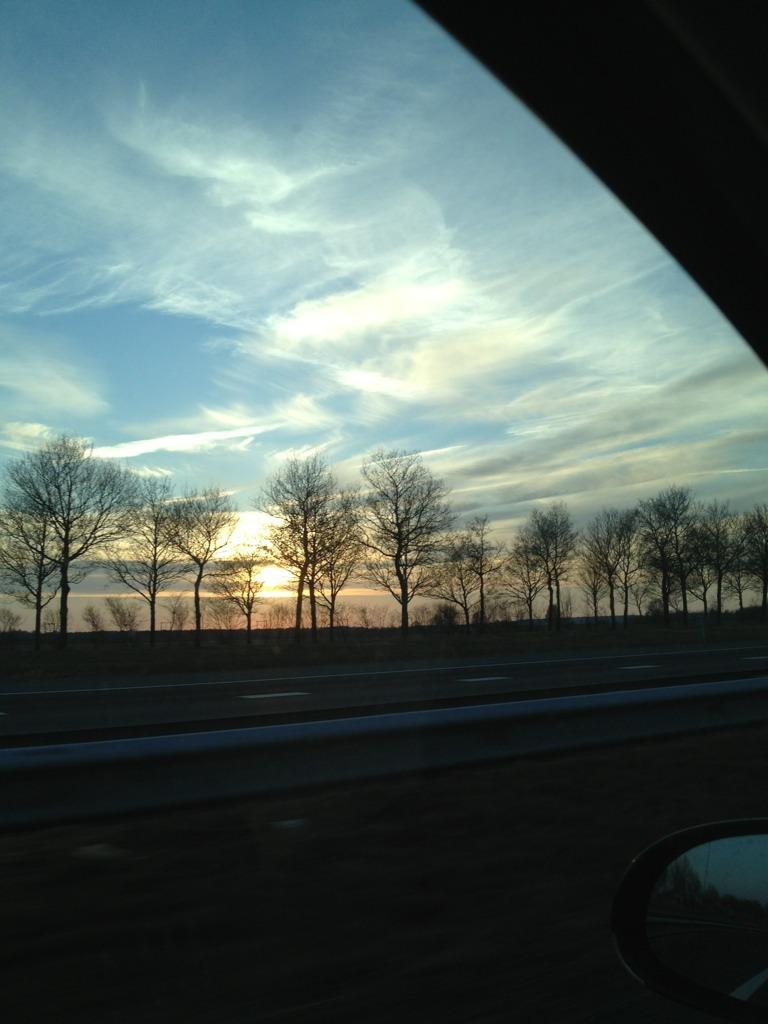What object in the image allows for reflection? There is a mirror in the image. What type of vehicle might the glass in the image belong to? There is a glass of a vehicle in the image. What type of natural environment is visible in the background of the image? There are trees in the background of the image. What is visible in the sky in the background of the image? The sky is visible in the background of the image. How many tents are set up in the image? There are no tents present in the image. What type of nail is being used to hold up the mirror in the image? There is no nail visible in the image, and the mirror is not being held up by any visible nails. 